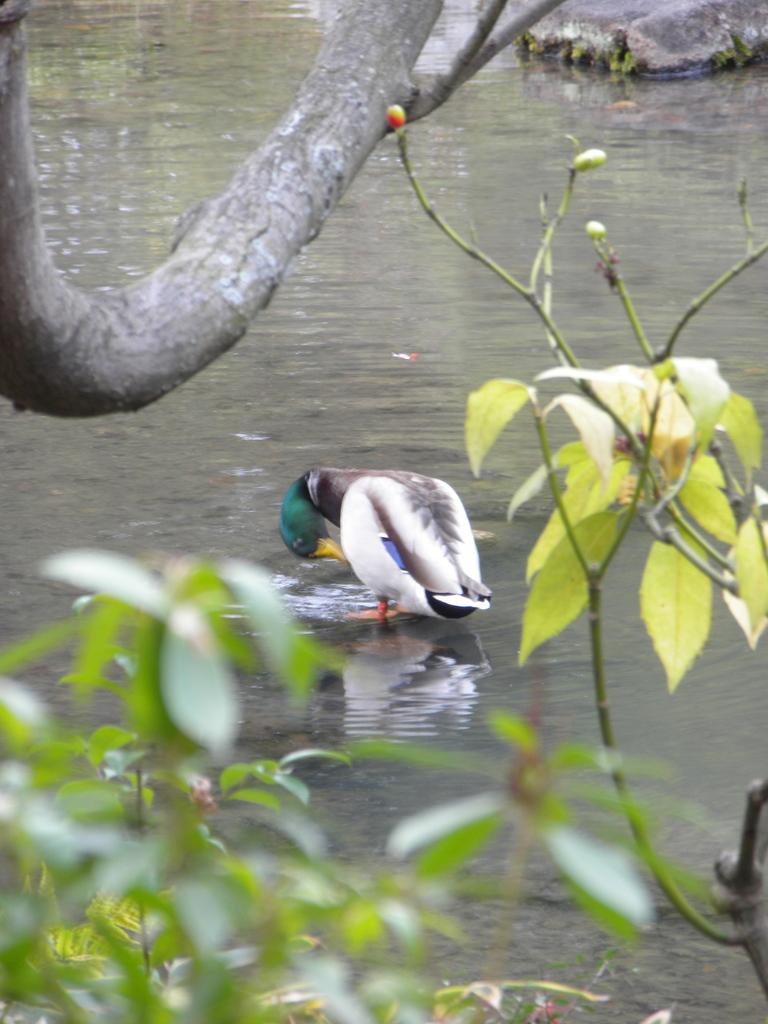What is the main subject in the center of the image? There is a bird in the center of the image. Where is the bird located? The bird is on the water. What type of vegetation can be seen at the bottom side of the image? There are plants at the bottom side of the image. What type of geological formation is present at the top side of the image? There are rocks at the top side of the image. What type of nerve can be seen in the image? There is no nerve present in the image; it features a bird on the water with plants and rocks in the background. 